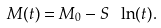<formula> <loc_0><loc_0><loc_500><loc_500>M ( t ) = M _ { 0 } - S \ \ln ( t ) .</formula> 